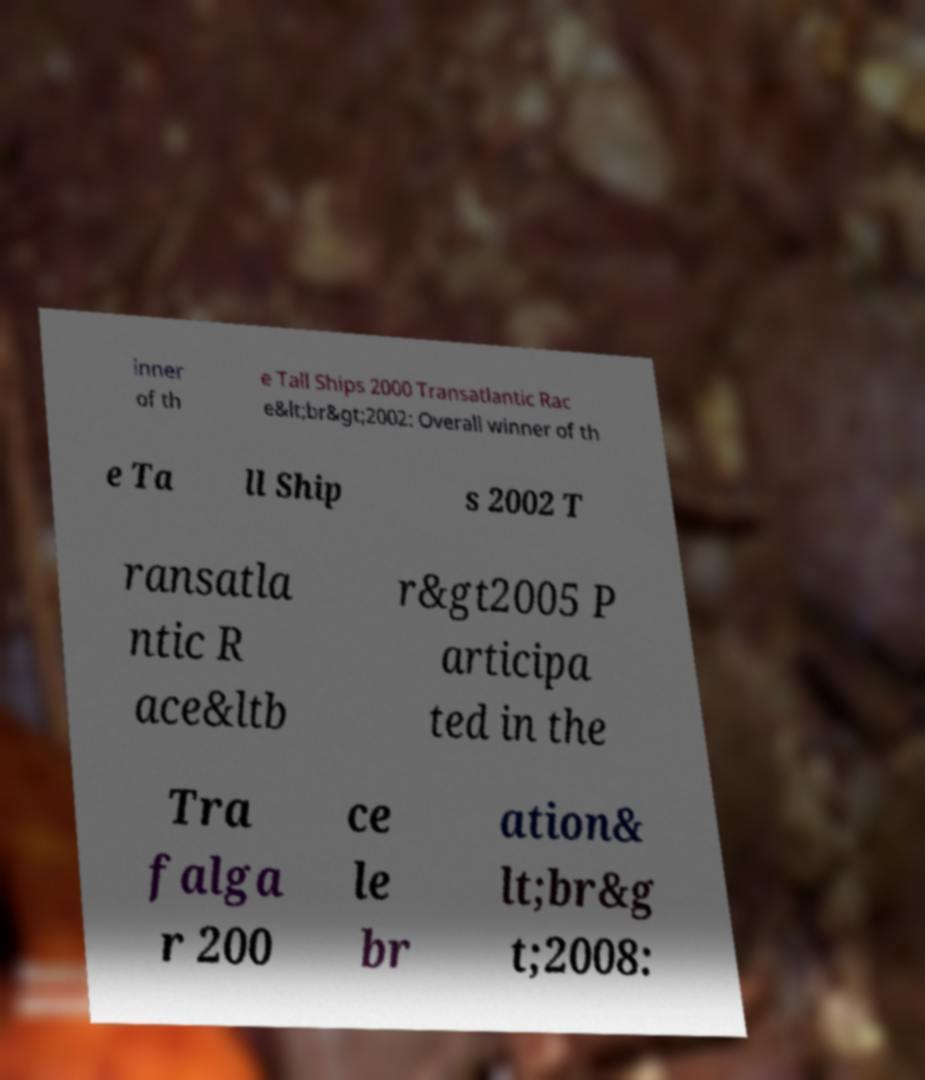Could you extract and type out the text from this image? inner of th e Tall Ships 2000 Transatlantic Rac e&lt;br&gt;2002: Overall winner of th e Ta ll Ship s 2002 T ransatla ntic R ace&ltb r&gt2005 P articipa ted in the Tra falga r 200 ce le br ation& lt;br&g t;2008: 